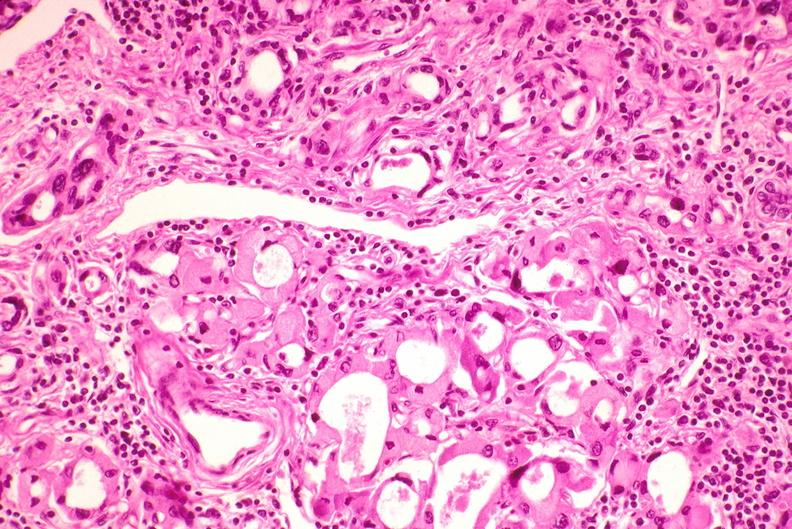does this image show thyroid, hashimoto 's?
Answer the question using a single word or phrase. Yes 